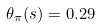Convert formula to latex. <formula><loc_0><loc_0><loc_500><loc_500>\theta _ { \pi } ( s ) = 0 . 2 9</formula> 